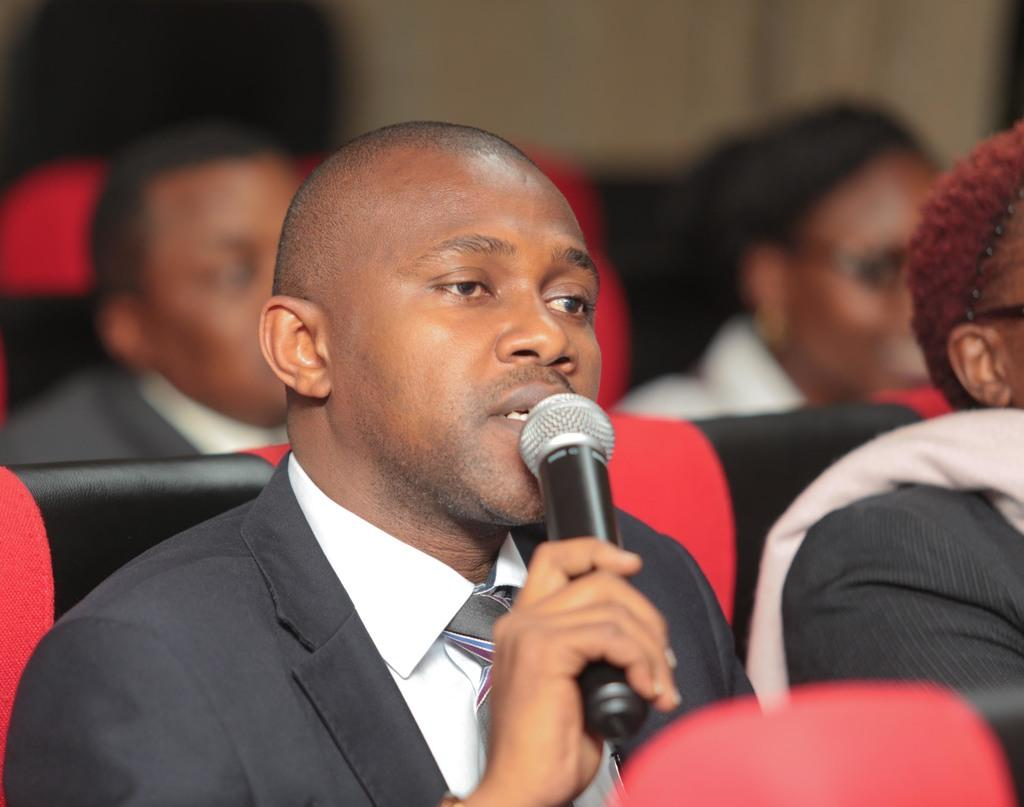What are the people in the image doing? The persons in the image are sitting on chairs. Can you describe any specific actions or objects being held by the people? One person is holding a microphone in their hand. Where is the bedroom located in the image? There is no bedroom present in the image. Can you describe the fly that is buzzing around the microphone? There is no fly present in the image. 